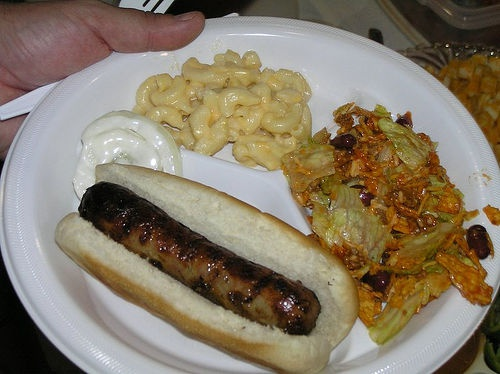Describe the objects in this image and their specific colors. I can see hot dog in black, darkgray, tan, and olive tones, people in black, brown, gray, and maroon tones, fork in black, darkgray, lightgray, and lavender tones, and fork in black, darkgray, and gray tones in this image. 